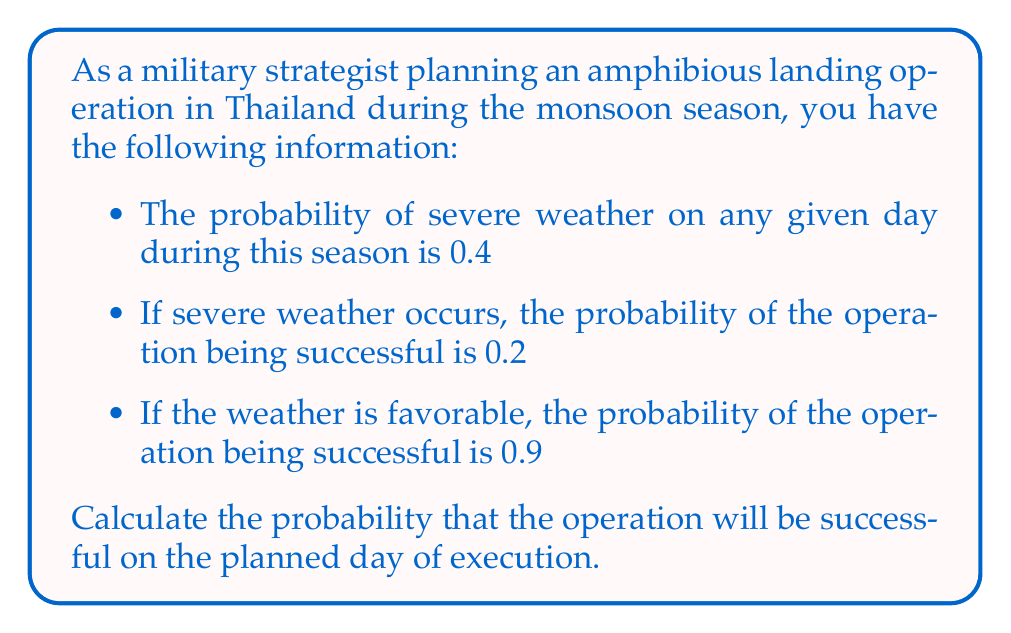Give your solution to this math problem. To solve this problem, we'll use Bayes' theorem and the law of total probability. Let's define our events:

$S$: The operation is successful
$W$: Severe weather occurs

We're given:
$P(W) = 0.4$
$P(S|W) = 0.2$
$P(S|\text{not }W) = 0.9$

We want to find $P(S)$. Using the law of total probability:

$$P(S) = P(S|W)P(W) + P(S|\text{not }W)P(\text{not }W)$$

We know $P(W) = 0.4$, so $P(\text{not }W) = 1 - 0.4 = 0.6$

Now, let's substitute the values:

$$\begin{align}
P(S) &= P(S|W)P(W) + P(S|\text{not }W)P(\text{not }W) \\
&= (0.2)(0.4) + (0.9)(0.6) \\
&= 0.08 + 0.54 \\
&= 0.62
\end{align}$$

Therefore, the probability that the operation will be successful on the planned day of execution is 0.62 or 62%.
Answer: $P(S) = 0.62$ or 62% 